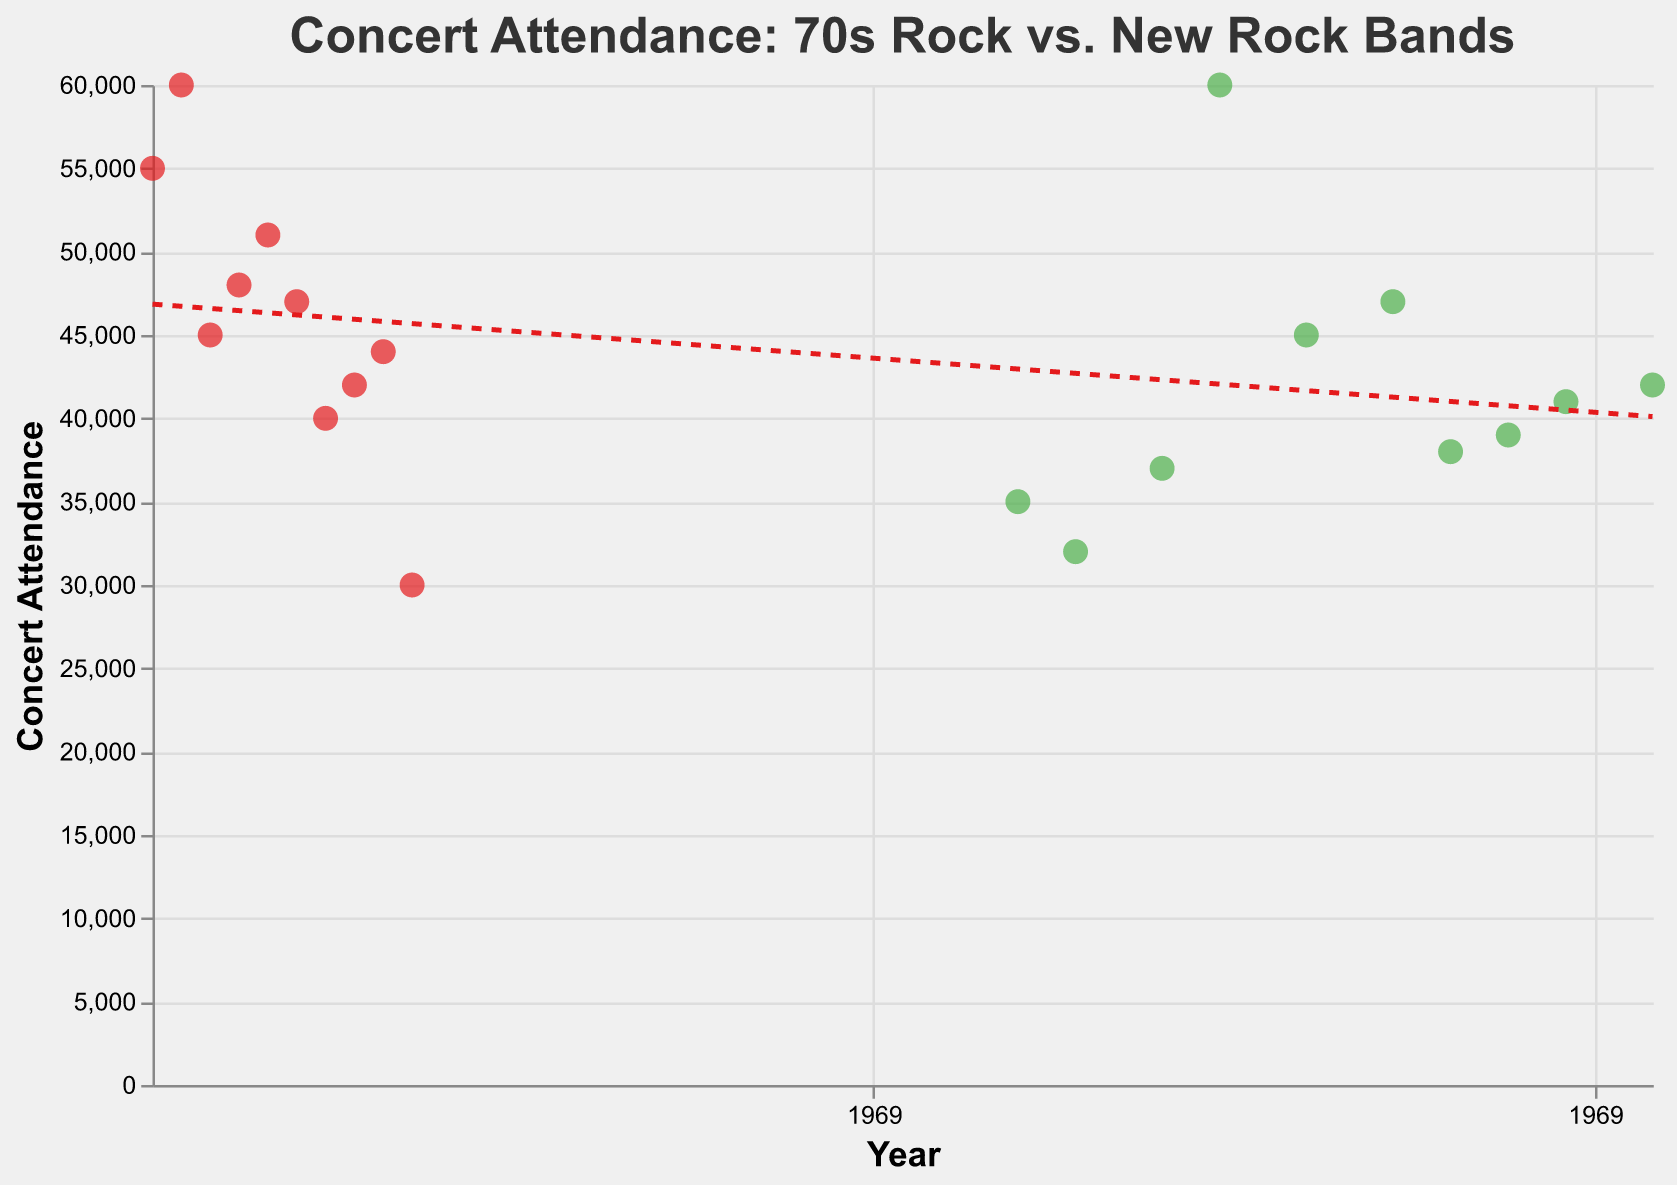What is the title of the figure? The title is the text placed at the top of the figure. In this case, the title states what the plot is about.
Answer: Concert Attendance: 70s Rock vs. New Rock Bands Which band had the highest concert attendance, and in which year? Identify the data point with the highest value on the y-axis (concert attendance) and check the corresponding band name and year from the tooltip.
Answer: Pink Floyd, 1971 How many data points represent 70s rock bands? The color of the data points differentiates 70s rock bands (usually red) from new rock bands (usually green). Count the red points.
Answer: 10 What is the average concert attendance for the new rock bands? Sum up the attendance values of new rock bands and divide by the number of those bands. Break it down:
(35,000 + 32,000 + 37,000 + 60,000 + 45,000 + 47,000 + 38,000 + 39,000 + 41,000 + 42,000) / 10 = 41,600
Answer: 41,600 Is there a trend between the years and concert attendance? Look at the trend line. If the line has a positive or negative slope, it indicates a trend.
Answer: Slightly declining trend Which band had the lowest concert attendance, and what was the attendance figure? Identify the data point with the lowest value on the y-axis, and check the band name and attendance from the tooltip.
Answer: Ramones, 30,000 Compare the concert attendance of Queen vs. Coldplay. Which band had a higher attendance and by how much? Locate both data points and compare their y-axis values. Calculate the difference. Queen: 51,000, Coldplay: 60,000, Difference: 60,000 - 51,000
Answer: Coldplay, by 9,000 What was the concert attendance for Led Zeppelin in 1970? Find the data point labeled "Led Zeppelin" and look at its y-value or check the tooltip.
Answer: 55,000 Which decade had more bands with concert attendance recorded in this dataset, the 70s or 2000s? Count the data points falling between 1970-1979 and 2000-2009. Compare the counts.
Answer: The 70s How does the trend line help in interpreting the data about concert attendance over the years? Analyze the direction and slope of the trend line; it shows whether the average concert attendance is increasing, decreasing, or stable over time.
Answer: Indicates a slightly declining trend 